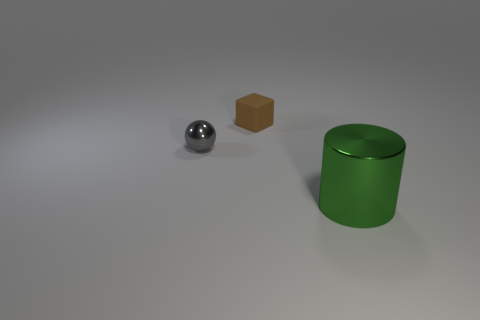Add 3 large brown rubber things. How many objects exist? 6 Subtract all cylinders. How many objects are left? 2 Subtract all tiny shiny balls. Subtract all big brown metal cylinders. How many objects are left? 2 Add 1 gray objects. How many gray objects are left? 2 Add 3 big yellow things. How many big yellow things exist? 3 Subtract 0 purple blocks. How many objects are left? 3 Subtract 1 blocks. How many blocks are left? 0 